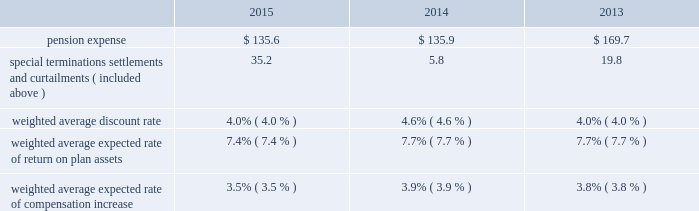Unconditional purchase obligations approximately $ 390 of our long-term unconditional purchase obligations relate to feedstock supply for numerous hyco ( hydrogen , carbon monoxide , and syngas ) facilities .
The price of feedstock supply is principally related to the price of natural gas .
However , long-term take-or-pay sales contracts to hyco customers are generally matched to the term of the feedstock supply obligations and provide recovery of price increases in the feedstock supply .
Due to the matching of most long-term feedstock supply obligations to customer sales contracts , we do not believe these purchase obligations would have a material effect on our financial condition or results of operations .
Refer to note 17 , commitments and contingencies , to the consolidated financial statements for additional information on our unconditional purchase obligations .
The unconditional purchase obligations also include other product supply and purchase commitments and electric power and natural gas supply purchase obligations , which are primarily pass-through contracts with our customers .
In addition , purchase commitments to spend approximately $ 540 for additional plant and equipment are included in the unconditional purchase obligations in 2016 .
We also purchase materials , energy , capital equipment , supplies , and services as part of the ordinary course of business under arrangements that are not unconditional purchase obligations .
The majority of such purchases are for raw materials and energy , which are obtained under requirements-type contracts at market prices .
Obligation for future contribution to an equity affiliate on 19 april 2015 , a joint venture between air products and acwa holding entered into a 20-year oxygen and nitrogen supply agreement to supply saudi aramco 2019s oil refinery and power plant being built in jazan , saudi arabia .
Air products owns 25% ( 25 % ) of the joint venture and guarantees the repayment of its share of an equity bridge loan .
In total , we expect to invest approximately $ 100 in this joint venture .
As of 30 september 2015 , we recorded a noncurrent liability of $ 67.5 for our obligation to make future equity contributions based on advances received by the joint venture under the loan .
Income tax liabilities noncurrent deferred income tax liabilities as of 30 september 2015 were $ 903.3 .
Tax liabilities related to unrecognized tax benefits as of 30 september 2015 were $ 97.5 .
These tax liabilities were excluded from the contractual obligations table , as it is impractical to determine a cash impact by year given that payments will vary according to changes in tax laws , tax rates , and our operating results .
In addition , there are uncertainties in timing of the effective settlement of our uncertain tax positions with respective taxing authorities .
Refer to note 23 , income taxes , to the consolidated financial statements for additional information .
Pension benefits the company sponsors defined benefit pension plans and defined contribution plans that cover a substantial portion of its worldwide employees .
The principal defined benefit pension plans 2014the u.s .
Salaried pension plan and the u.k .
Pension plan 2014were closed to new participants in 2005 and were replaced with defined contribution plans .
Over the long run , the shift to defined contribution plans is expected to reduce volatility of both plan expense and contributions .
The fair market value of plan assets for our defined benefit pension plans as of the 30 september 2015 measurement date decreased to $ 3916.4 from $ 4114.6 at the end of fiscal year 2014 .
The projected benefit obligation for these plans was $ 4787.8 and $ 4738.6 at the end of the fiscal years 2015 and 2014 , respectively .
Refer to note 16 , retirement benefits , to the consolidated financial statements for comprehensive and detailed disclosures on our postretirement benefits .
Pension expense .

What are the average pension expenses for those three years? 
Rationale: it is the sum of all pension expenses divided by three ( number of years ) .
Computations: table_average(pension expense, none)
Answer: 147.06667. 